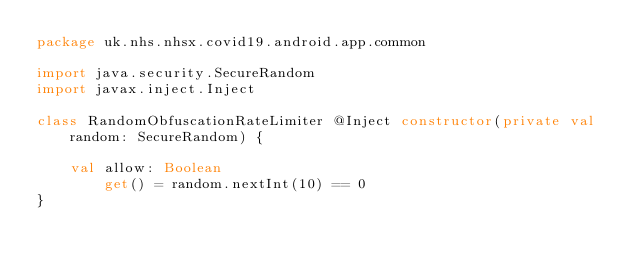<code> <loc_0><loc_0><loc_500><loc_500><_Kotlin_>package uk.nhs.nhsx.covid19.android.app.common

import java.security.SecureRandom
import javax.inject.Inject

class RandomObfuscationRateLimiter @Inject constructor(private val random: SecureRandom) {

    val allow: Boolean
        get() = random.nextInt(10) == 0
}
</code> 